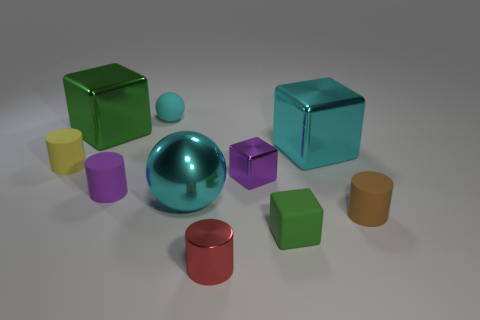What is the size of the cyan object that is the same material as the tiny green cube?
Give a very brief answer. Small. There is another sphere that is the same color as the metal ball; what is its size?
Offer a terse response. Small. How many other things are the same size as the red thing?
Offer a very short reply. 6. There is a purple object on the right side of the red shiny cylinder; what is its material?
Offer a terse response. Metal. What is the shape of the tiny thing to the right of the green block that is to the right of the large cube behind the cyan metal block?
Your answer should be very brief. Cylinder. Is the size of the cyan metallic sphere the same as the green shiny object?
Your answer should be very brief. Yes. How many objects are small balls or small objects that are in front of the large green metal cube?
Make the answer very short. 7. How many objects are cyan metallic things behind the tiny purple metallic cube or rubber cylinders that are right of the yellow thing?
Your answer should be compact. 3. There is a tiny yellow matte cylinder; are there any green shiny things behind it?
Ensure brevity in your answer.  Yes. There is a sphere right of the matte object behind the tiny cylinder that is on the left side of the big green block; what is its color?
Provide a succinct answer. Cyan. 